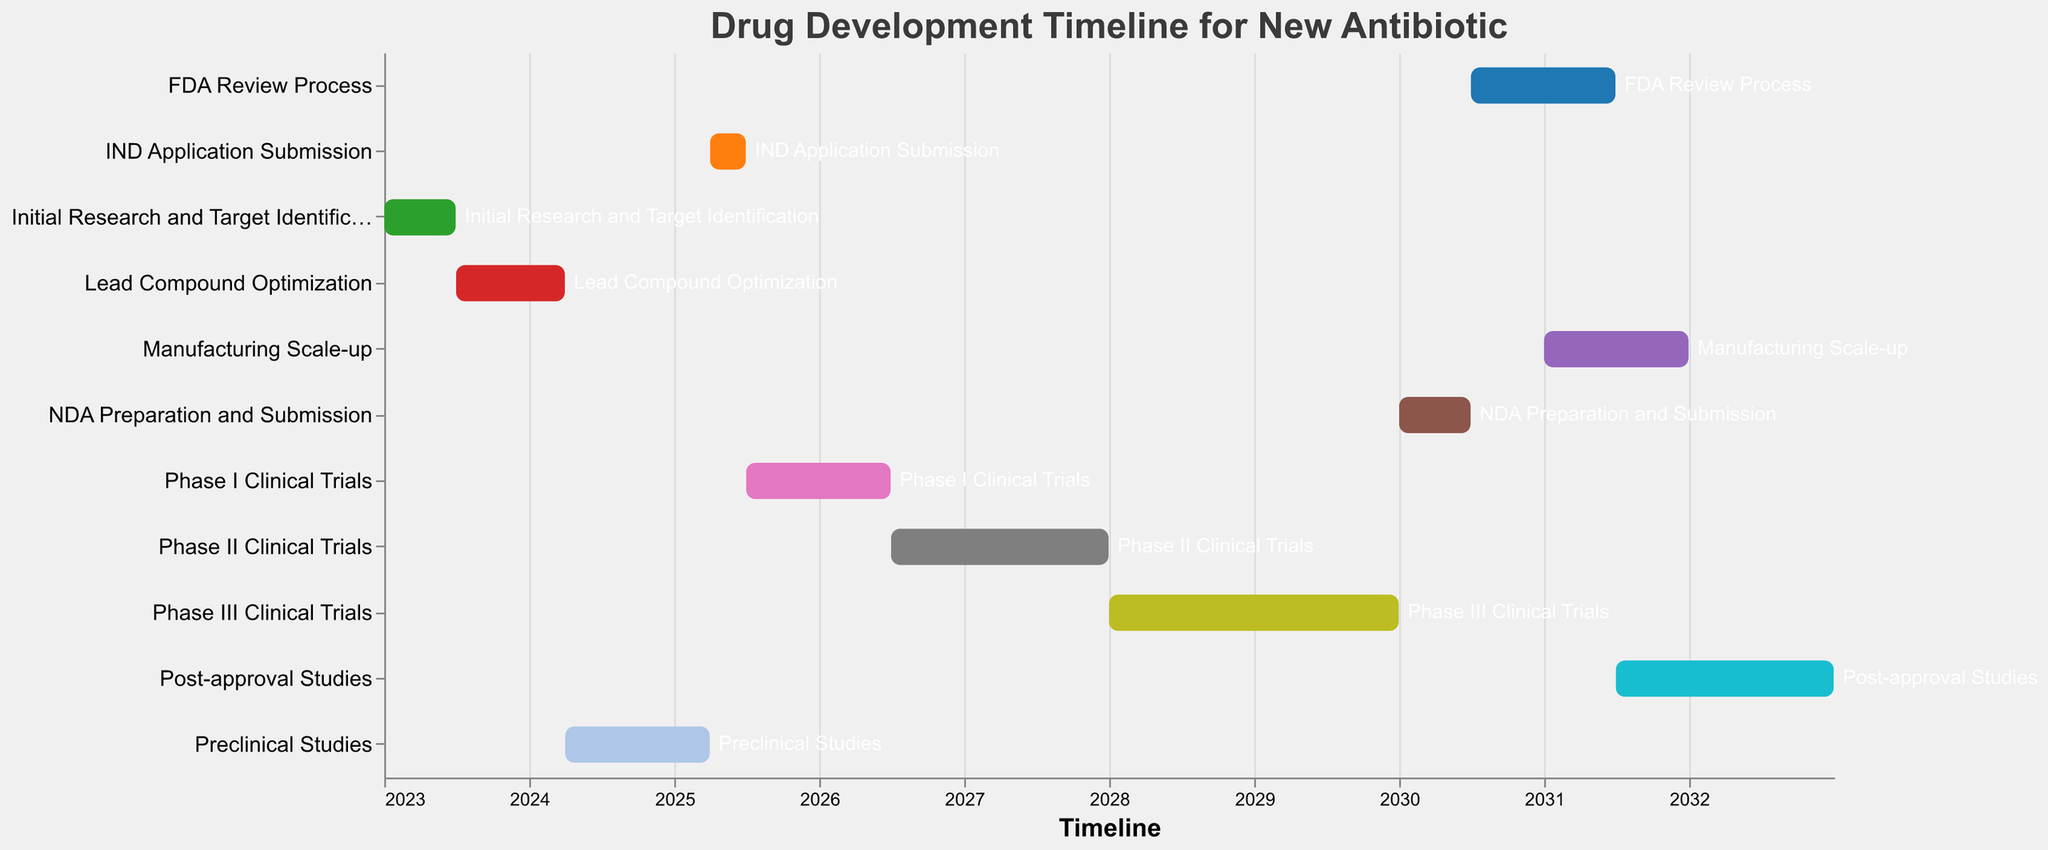What's the title of the chart? The title is located at the top of the chart and it reads "Drug Development Timeline for New Antibiotic".
Answer: Drug Development Timeline for New Antibiotic Which phase comes after Lead Compound Optimization? Referring to the order of tasks in the vertical axis, the phase that follows Lead Compound Optimization is Preclinical Studies.
Answer: Preclinical Studies How long does the FDA Review Process take? The FDA Review Process starts in July 2030 and ends in June 2031. Calculating the duration: July 2030 to July 2031 is 12 months, then remove one month (June itself) gives us 12 months in total.
Answer: 12 months Which phase has the longest duration? By measuring the start and end dates of each phase, it’s clear that the Phase III Clinical Trials, spanning from January 2028 to December 2029, has the longest duration of 24 months.
Answer: Phase III Clinical Trials What is the total time span from Initial Research and Target Identification to Post-approval Studies? Initial Research and Target Identification starts in January 2023, and Post-approval Studies end in December 2032. Calculating from January 2023 to January 2033 gives us 10 years, and subtracting one month for December, the total is 10 years.
Answer: 10 years Which task overlaps with FDA Review Process? By checking the durations on the timeline, the Manufacturing Scale-up overlaps with the FDA Review Process, running from January 2031 to December 2031 while the FDA Review happens from July 2030 to June 2031.
Answer: Manufacturing Scale-up What's the duration of Preclinical Studies compared to that of IND Application Submission? Preclinical Studies span from April 2024 to March 2025, which is 12 months. IND Application Submission spans from April 2025 to June 2025, which is 3 months. Compared together: 12 months > 3 months.
Answer: Preclinical Studies are longer Between Phase I and Phase II Clinical Trials, which one takes longer? Phase I Clinical Trials are from July 2025 to June 2026, lasting 12 months. Phase II Clinical Trials are from July 2026 to December 2027, lasting 18 months. Thus, Phase II is longer.
Answer: Phase II Clinical Trials During which period does NDA Preparation and Submission occur? Looking at the chart, NDA Preparation and Submission occurs from January 2030 to June 2030.
Answer: January 2030 to June 2030 